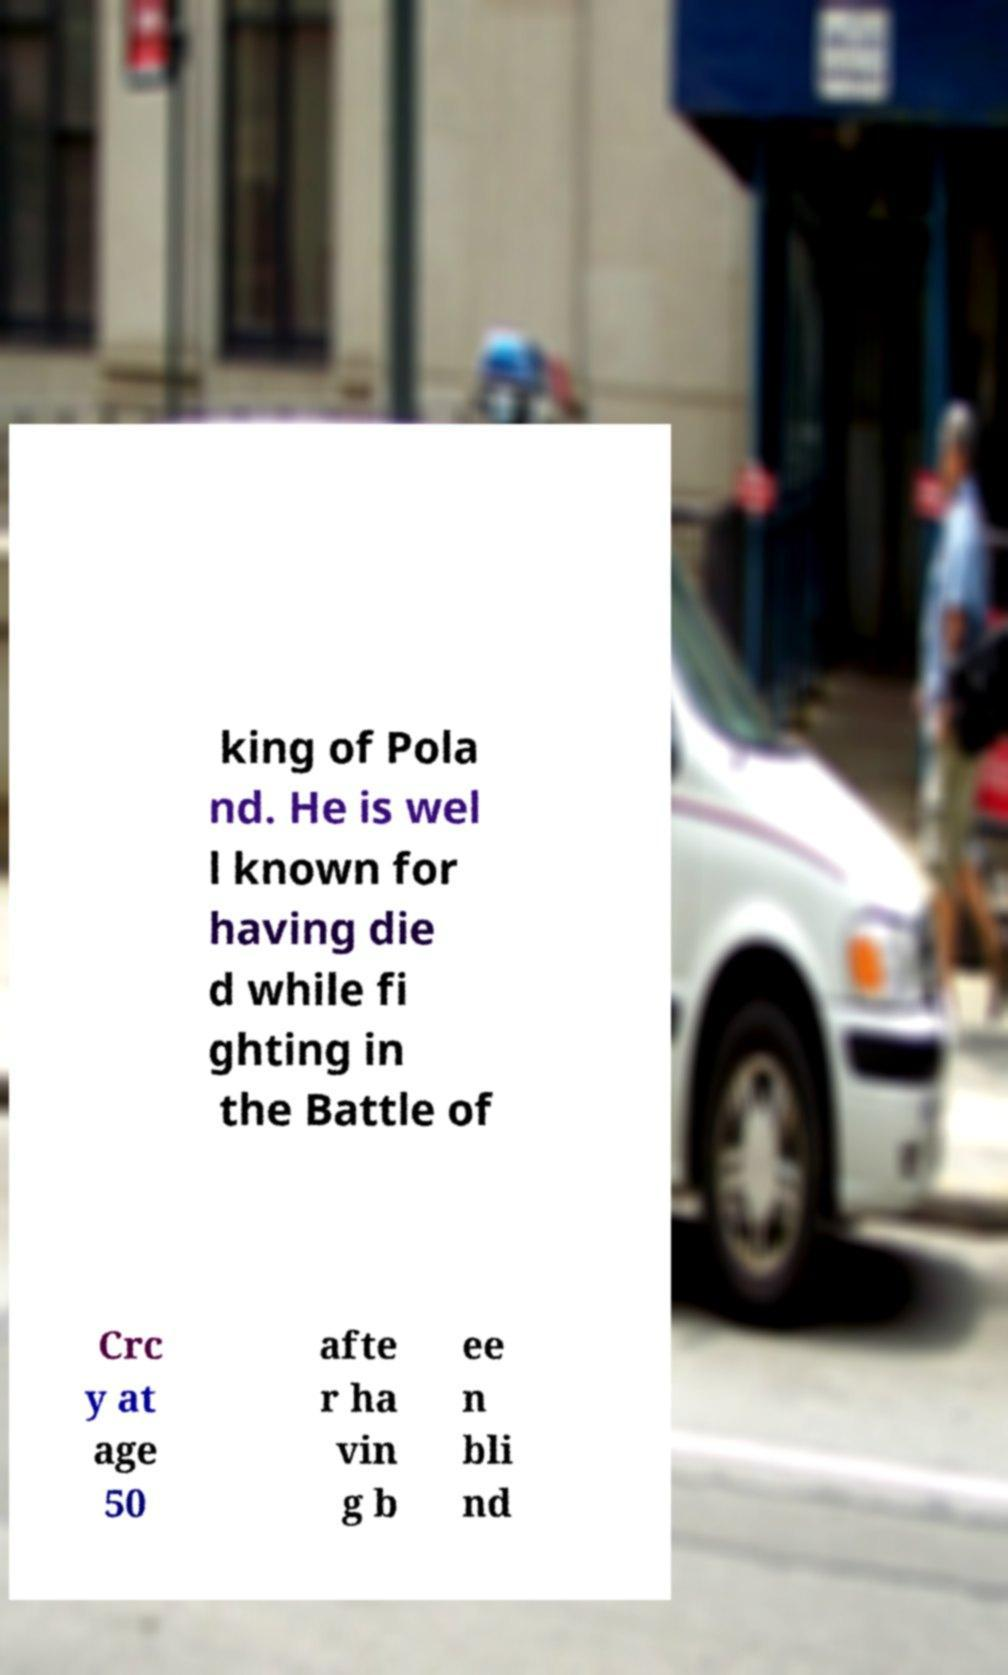What messages or text are displayed in this image? I need them in a readable, typed format. king of Pola nd. He is wel l known for having die d while fi ghting in the Battle of Crc y at age 50 afte r ha vin g b ee n bli nd 